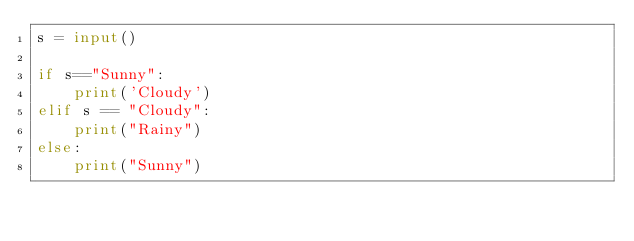Convert code to text. <code><loc_0><loc_0><loc_500><loc_500><_Python_>s = input()

if s=="Sunny":
    print('Cloudy')
elif s == "Cloudy":
    print("Rainy")
else:
    print("Sunny")</code> 